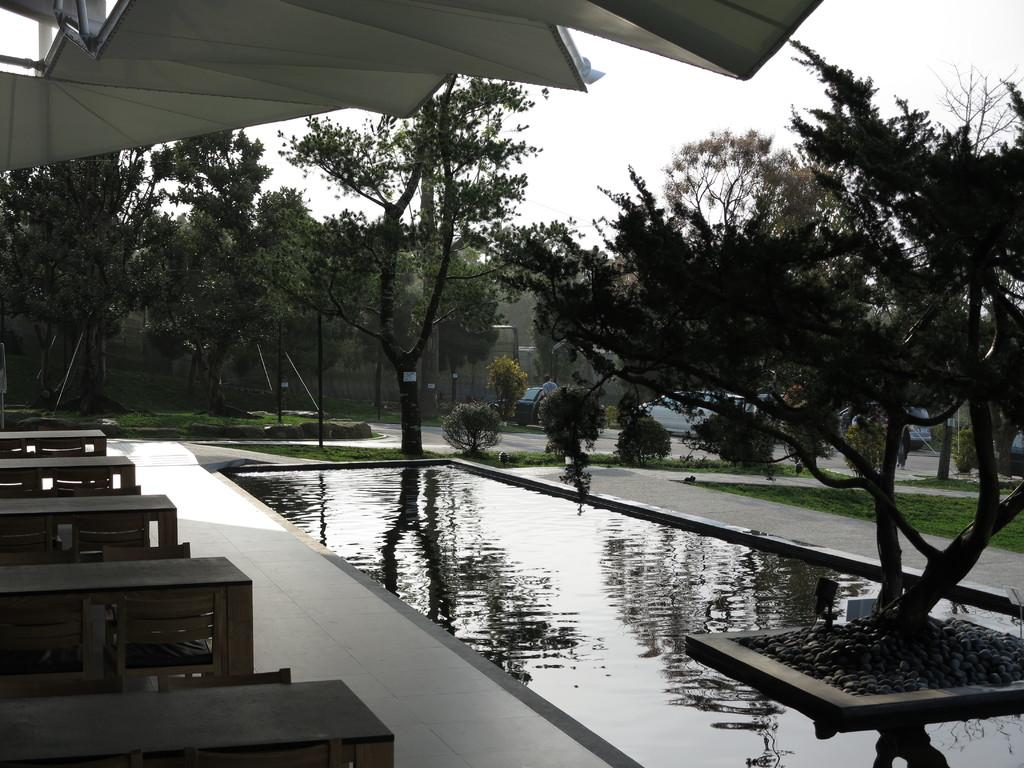What is the primary element visible in the image? There is water in the image. What type of vegetation can be seen in the image? There are trees in the image. What type of furniture is present in the image? There are tables and chairs in the image. What is the ground covered with in the image? There is grass on the ground in the image. What type of vehicles are parked in the image? There are cars parked in the image. Can you describe the man standing in the image? There is a man standing in the image. What is the condition of the sky in the image? The sky is cloudy in the image. How does the man blow a knot in the image? There is no knot present in the image, and the man is not blowing anything. 